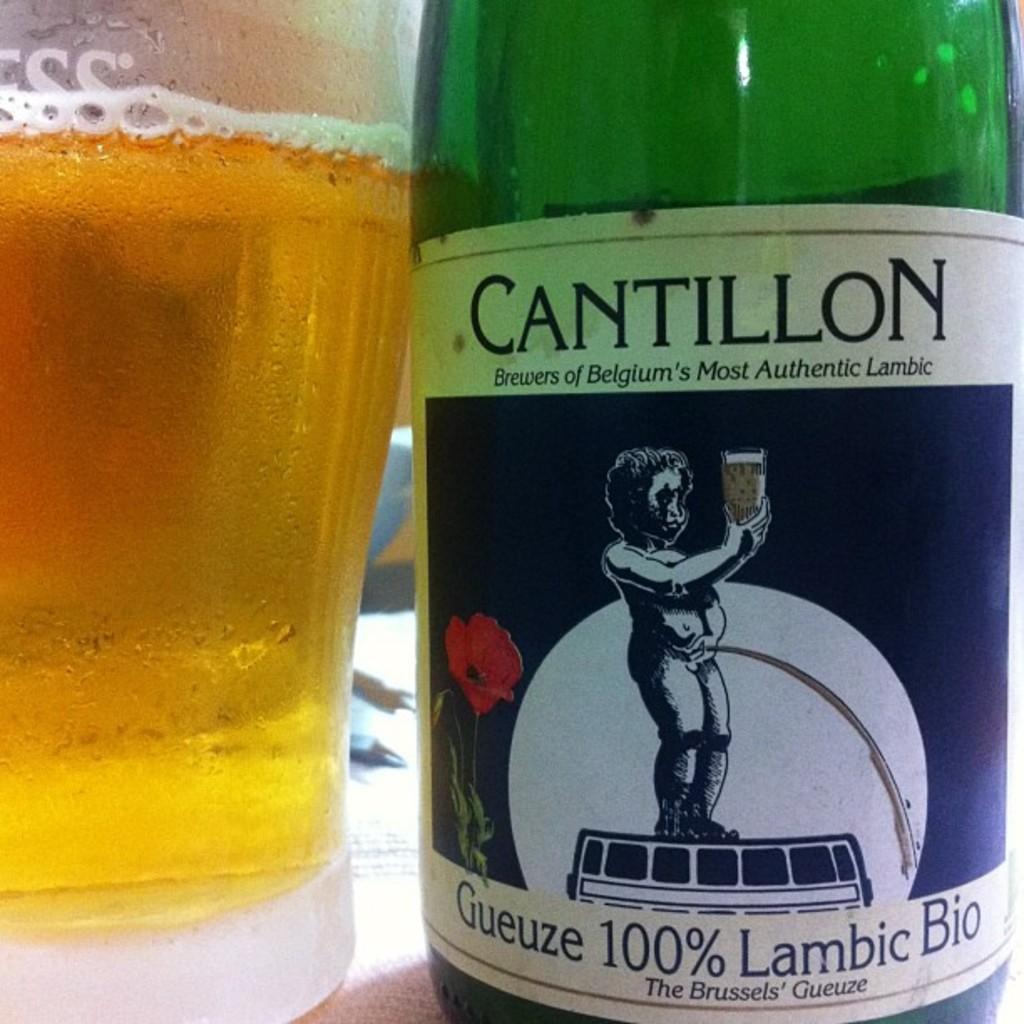Is this 100%?
Ensure brevity in your answer.  Yes. What brand of drink is this?
Give a very brief answer. Cantillon. 